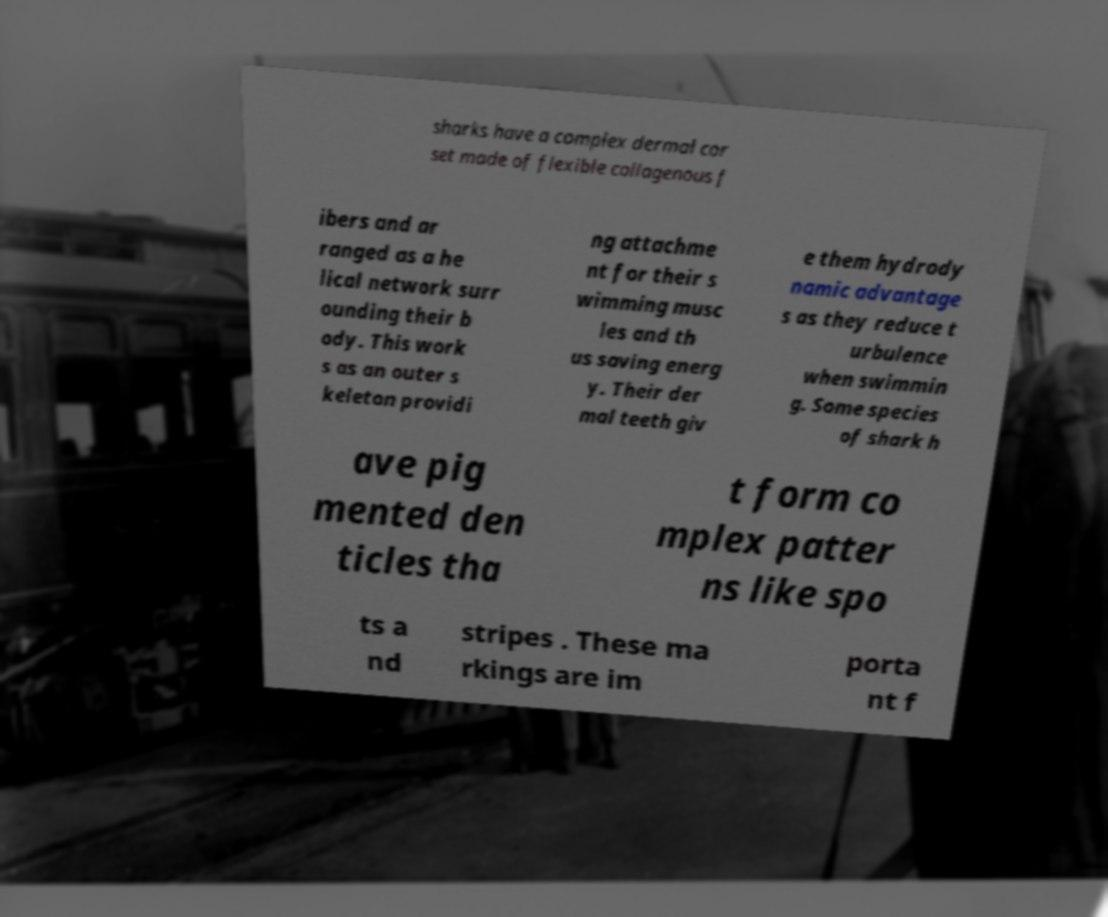There's text embedded in this image that I need extracted. Can you transcribe it verbatim? sharks have a complex dermal cor set made of flexible collagenous f ibers and ar ranged as a he lical network surr ounding their b ody. This work s as an outer s keleton providi ng attachme nt for their s wimming musc les and th us saving energ y. Their der mal teeth giv e them hydrody namic advantage s as they reduce t urbulence when swimmin g. Some species of shark h ave pig mented den ticles tha t form co mplex patter ns like spo ts a nd stripes . These ma rkings are im porta nt f 